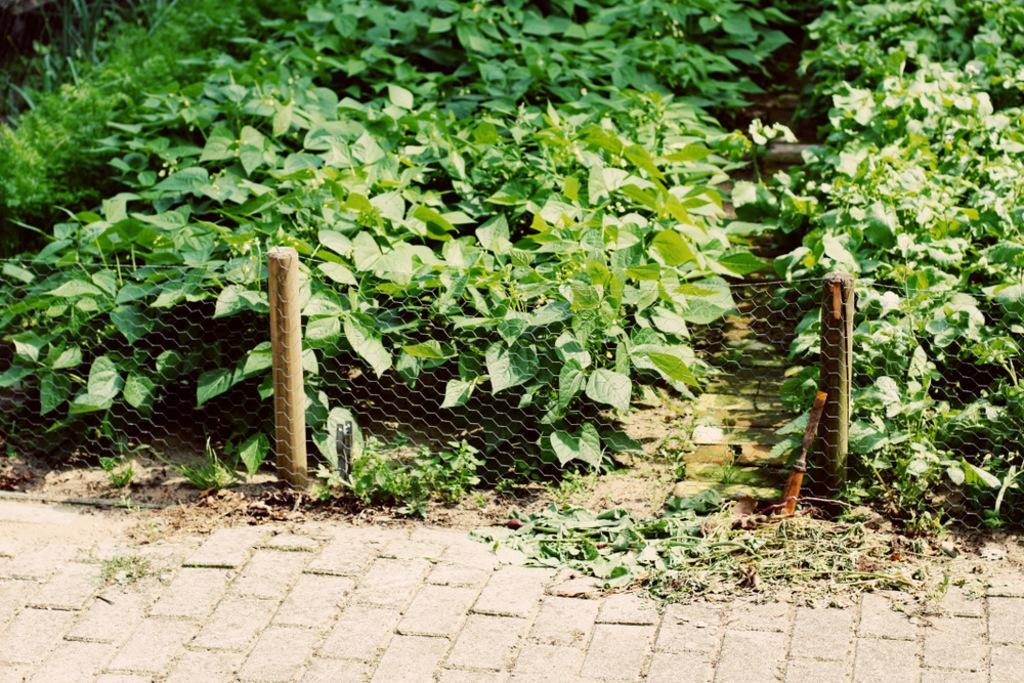What type of barrier can be seen in the image? There is a fence in the image. What type of vegetation is present in the image? There are green plants in the image. What type of apparel is being worn by the bushes in the image? There are no bushes or apparel present in the image. What is the height of the low plants in the image? There are no plants mentioned as being low in the image; only green plants are mentioned. 